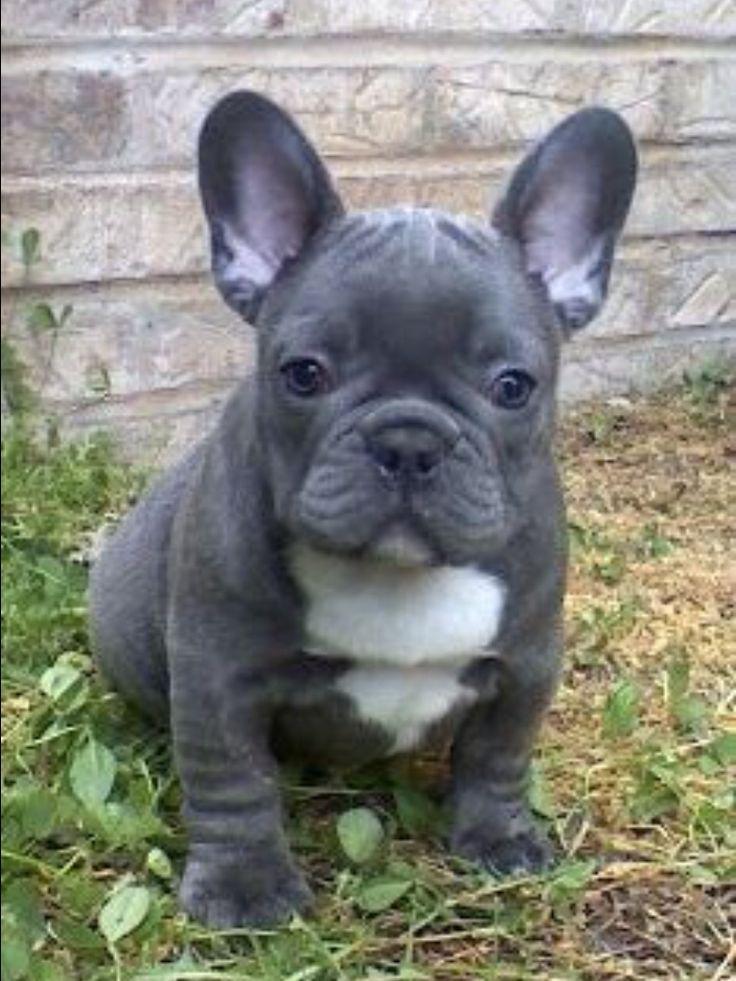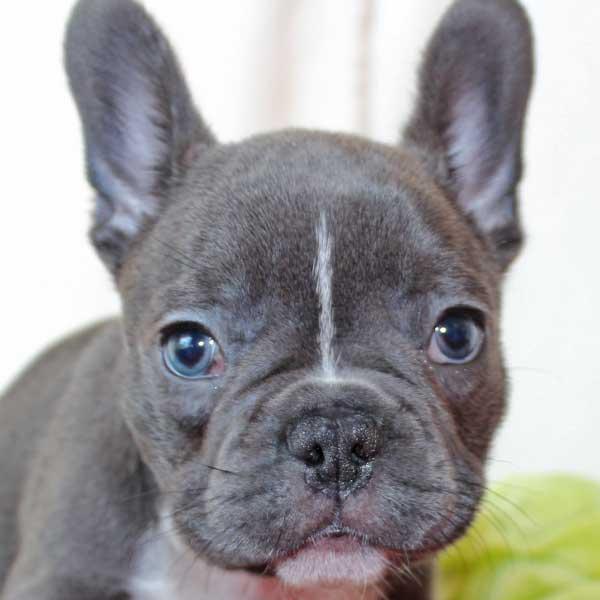The first image is the image on the left, the second image is the image on the right. Evaluate the accuracy of this statement regarding the images: "Left image features one sitting puppy with dark gray fur and a white chest marking.". Is it true? Answer yes or no. Yes. 